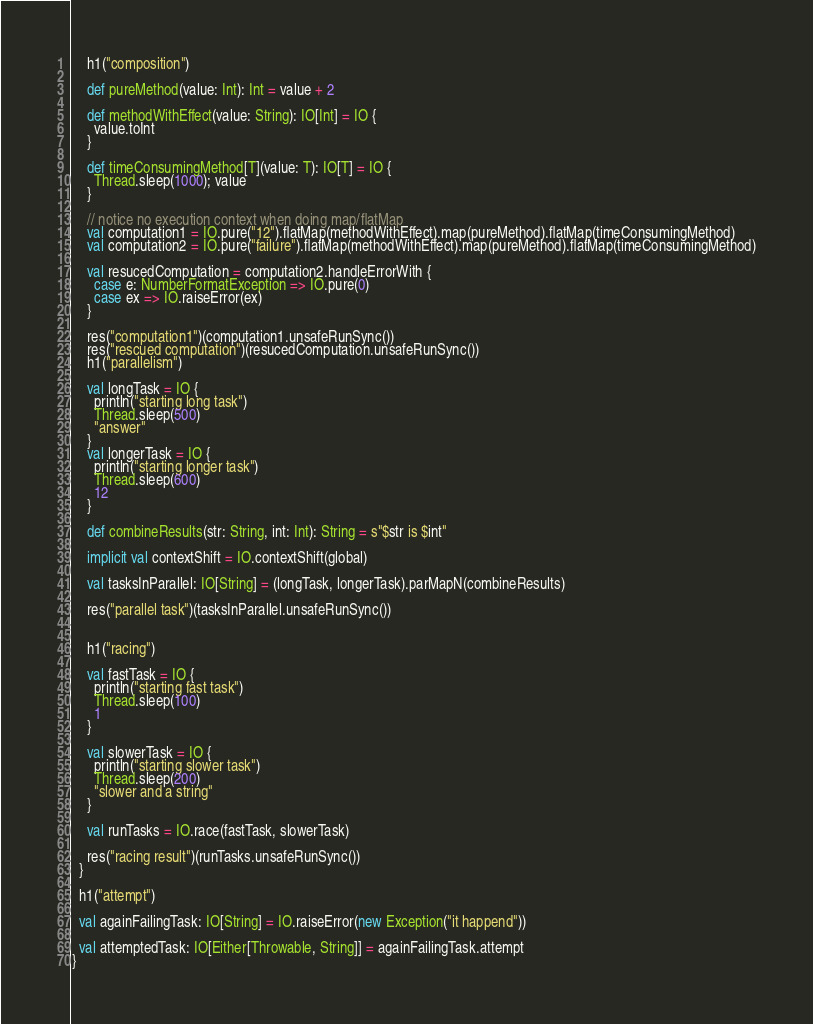<code> <loc_0><loc_0><loc_500><loc_500><_Scala_>
    h1("composition")

    def pureMethod(value: Int): Int = value + 2

    def methodWithEffect(value: String): IO[Int] = IO {
      value.toInt
    }

    def timeConsumingMethod[T](value: T): IO[T] = IO {
      Thread.sleep(1000); value
    }

    // notice no execution context when doing map/flatMap
    val computation1 = IO.pure("12").flatMap(methodWithEffect).map(pureMethod).flatMap(timeConsumingMethod)
    val computation2 = IO.pure("failure").flatMap(methodWithEffect).map(pureMethod).flatMap(timeConsumingMethod)

    val resucedComputation = computation2.handleErrorWith {
      case e: NumberFormatException => IO.pure(0)
      case ex => IO.raiseError(ex)
    }

    res("computation1")(computation1.unsafeRunSync())
    res("rescued computation")(resucedComputation.unsafeRunSync())
    h1("parallelism")

    val longTask = IO {
      println("starting long task")
      Thread.sleep(500)
      "answer"
    }
    val longerTask = IO {
      println("starting longer task")
      Thread.sleep(600)
      12
    }

    def combineResults(str: String, int: Int): String = s"$str is $int"

    implicit val contextShift = IO.contextShift(global)

    val tasksInParallel: IO[String] = (longTask, longerTask).parMapN(combineResults)

    res("parallel task")(tasksInParallel.unsafeRunSync())


    h1("racing")

    val fastTask = IO {
      println("starting fast task")
      Thread.sleep(100)
      1
    }

    val slowerTask = IO {
      println("starting slower task")
      Thread.sleep(200)
      "slower and a string"
    }

    val runTasks = IO.race(fastTask, slowerTask)

    res("racing result")(runTasks.unsafeRunSync())
  }

  h1("attempt")

  val againFailingTask: IO[String] = IO.raiseError(new Exception("it happend"))

  val attemptedTask: IO[Either[Throwable, String]] = againFailingTask.attempt
}
</code> 